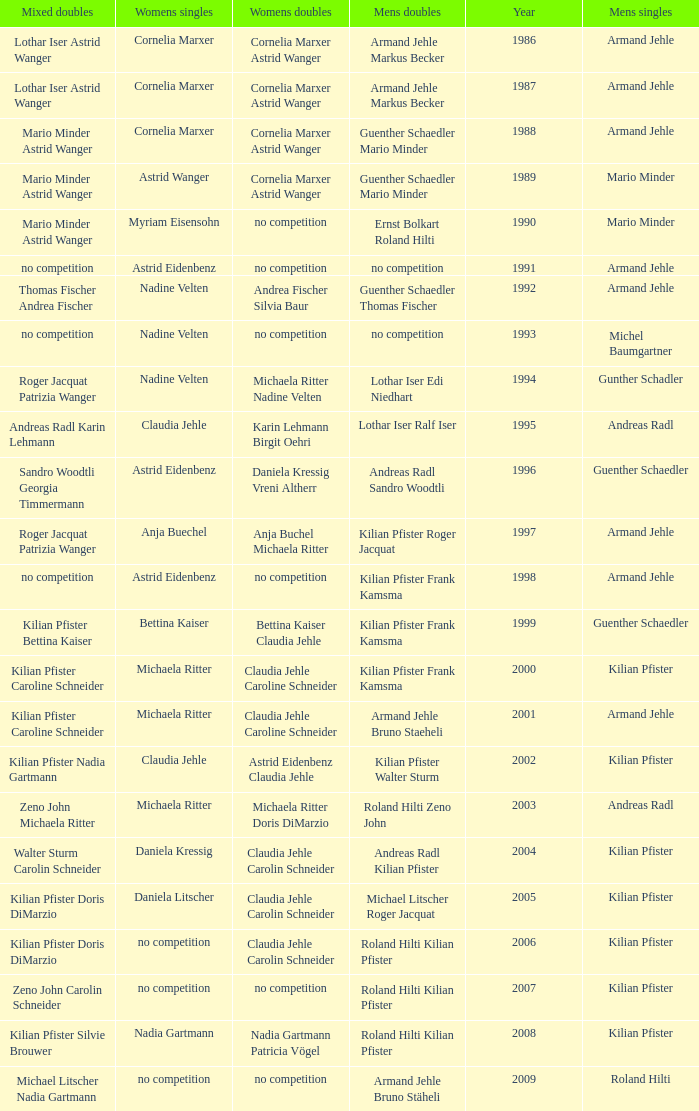In 1987 who was the mens singles Armand Jehle. 